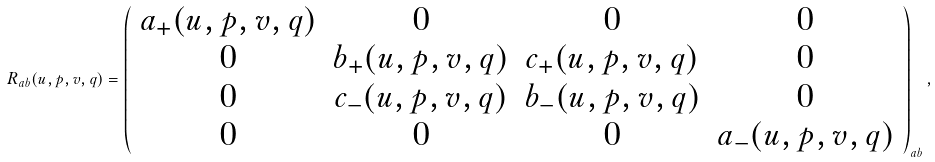<formula> <loc_0><loc_0><loc_500><loc_500>R _ { a b } ( u , p , v , q ) = \left ( \begin{array} { c c c c } a _ { + } ( u , p , v , q ) & 0 & 0 & 0 \\ 0 & b _ { + } ( u , p , v , q ) & c _ { + } ( u , p , v , q ) & 0 \\ 0 & c _ { - } ( u , p , v , q ) & b _ { - } ( u , p , v , q ) & 0 \\ 0 & 0 & 0 & a _ { - } ( u , p , v , q ) \end{array} \right ) _ { a b } ,</formula> 